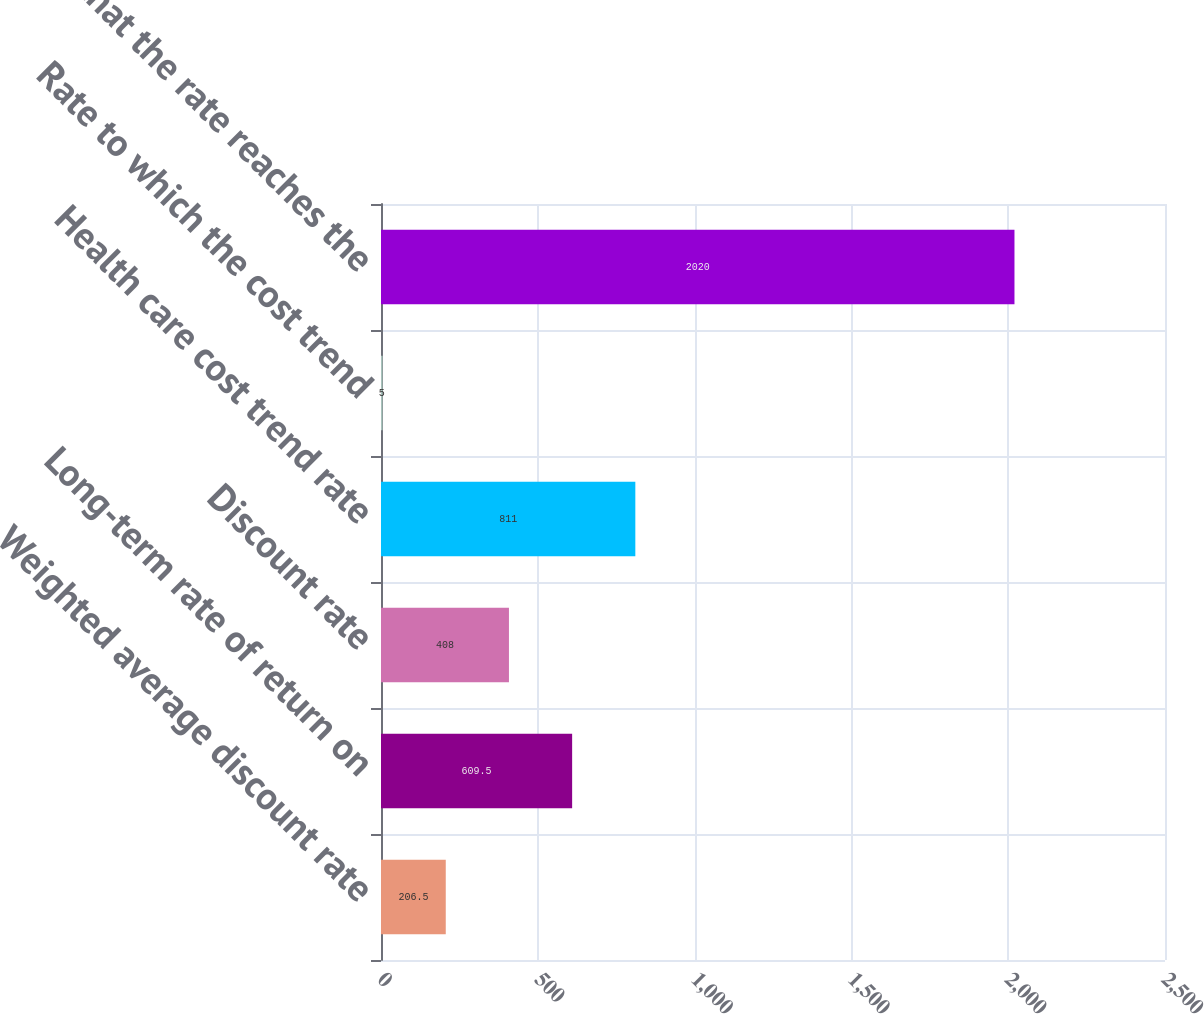Convert chart. <chart><loc_0><loc_0><loc_500><loc_500><bar_chart><fcel>Weighted average discount rate<fcel>Long-term rate of return on<fcel>Discount rate<fcel>Health care cost trend rate<fcel>Rate to which the cost trend<fcel>Year that the rate reaches the<nl><fcel>206.5<fcel>609.5<fcel>408<fcel>811<fcel>5<fcel>2020<nl></chart> 